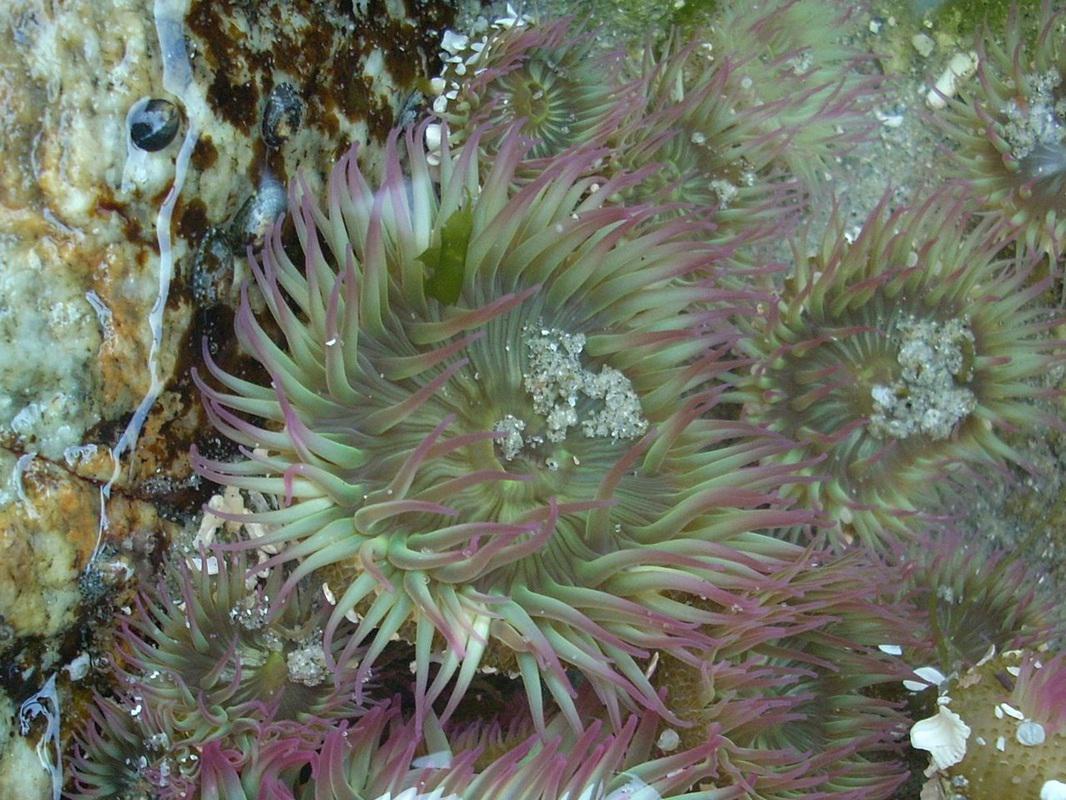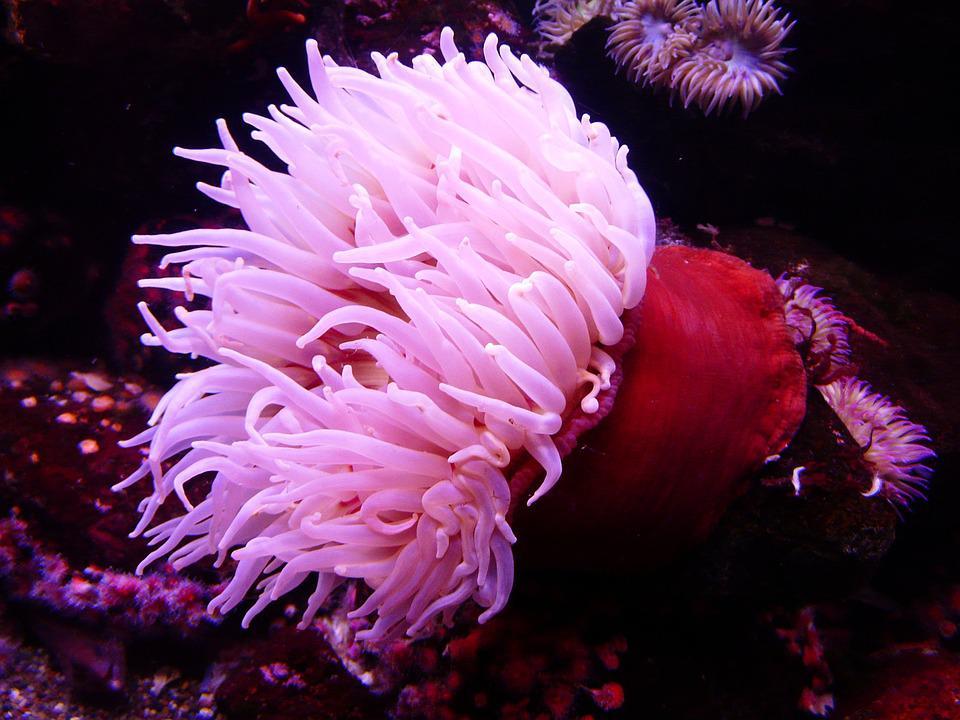The first image is the image on the left, the second image is the image on the right. Examine the images to the left and right. Is the description "An image shows the spotted pink stalk of one anemone." accurate? Answer yes or no. No. The first image is the image on the left, the second image is the image on the right. Analyze the images presented: Is the assertion "There are more sea plants in the image on the left than in the image on the right." valid? Answer yes or no. Yes. 